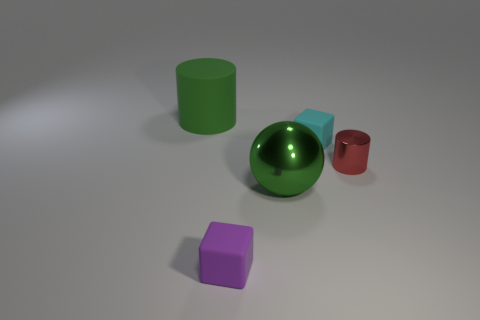Are there fewer objects to the left of the tiny purple cube than large brown matte balls?
Provide a short and direct response. No. Are there any green spheres that have the same size as the red cylinder?
Your answer should be compact. No. There is a sphere; does it have the same color as the rubber block that is behind the tiny purple object?
Give a very brief answer. No. What number of green metal spheres are to the right of the rubber block that is behind the tiny red metallic object?
Your answer should be very brief. 0. What is the color of the big thing in front of the large thing that is behind the small cyan object?
Your response must be concise. Green. What material is the object that is behind the small purple cube and in front of the red cylinder?
Keep it short and to the point. Metal. Is there another tiny thing of the same shape as the tiny metallic object?
Provide a short and direct response. No. Is the shape of the green object that is behind the tiny red object the same as  the red metal object?
Provide a short and direct response. Yes. How many objects are to the right of the purple matte cube and behind the large metallic thing?
Ensure brevity in your answer.  2. What shape is the shiny thing that is on the left side of the tiny cyan object?
Your answer should be compact. Sphere. 